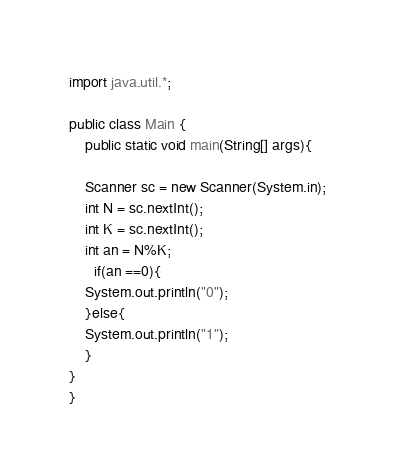<code> <loc_0><loc_0><loc_500><loc_500><_Java_>import java.util.*;

public class Main {
    public static void main(String[] args){
    
    Scanner sc = new Scanner(System.in);
    int N = sc.nextInt();
    int K = sc.nextInt();
	int an = N%K;
      if(an ==0){
    System.out.println("0");
    }else{
    System.out.println("1");      
    }
}
}</code> 